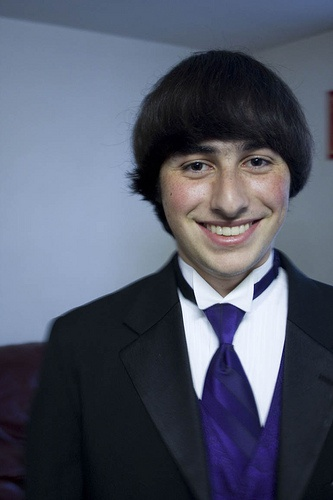Describe the objects in this image and their specific colors. I can see people in gray, black, navy, lavender, and darkgray tones and tie in gray, navy, darkblue, and lavender tones in this image. 